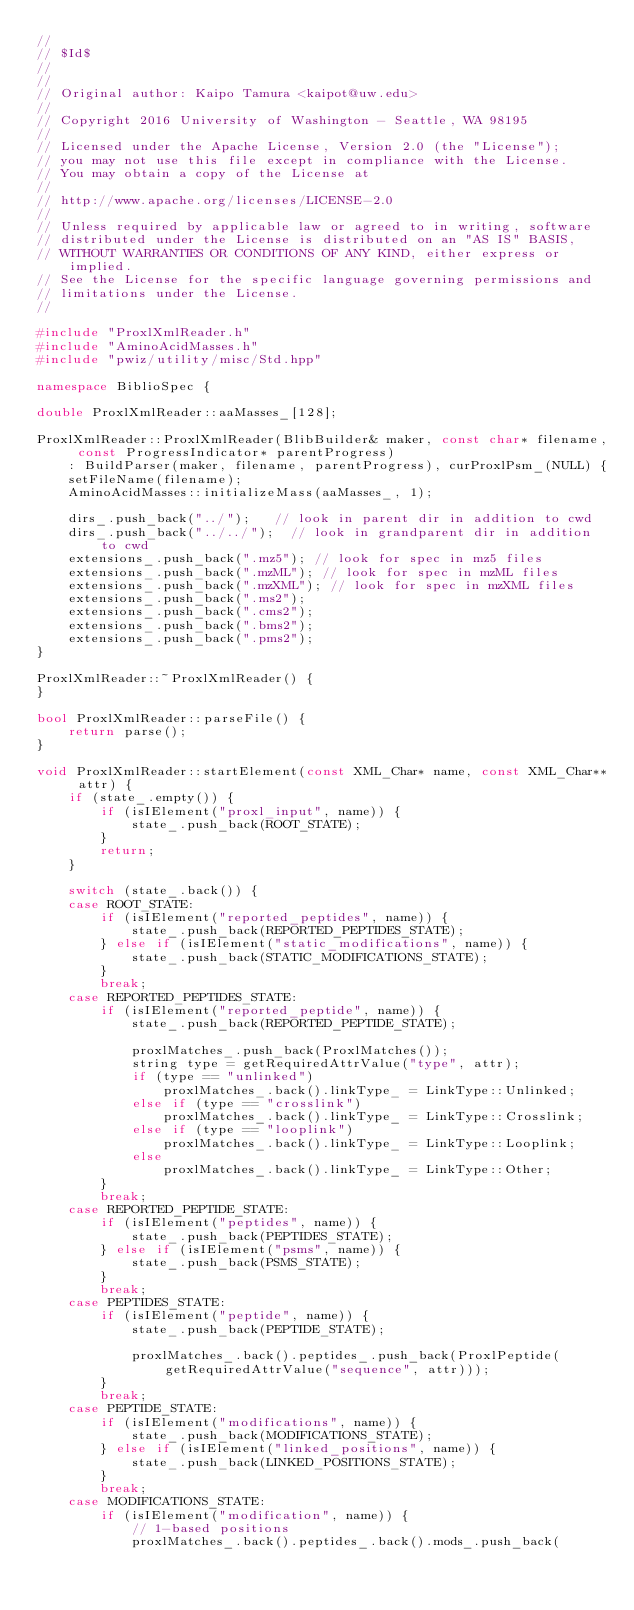Convert code to text. <code><loc_0><loc_0><loc_500><loc_500><_C++_>//
// $Id$
//
//
// Original author: Kaipo Tamura <kaipot@uw.edu>
//
// Copyright 2016 University of Washington - Seattle, WA 98195
//
// Licensed under the Apache License, Version 2.0 (the "License"); 
// you may not use this file except in compliance with the License. 
// You may obtain a copy of the License at 
//
// http://www.apache.org/licenses/LICENSE-2.0
//
// Unless required by applicable law or agreed to in writing, software 
// distributed under the License is distributed on an "AS IS" BASIS, 
// WITHOUT WARRANTIES OR CONDITIONS OF ANY KIND, either express or implied. 
// See the License for the specific language governing permissions and 
// limitations under the License.
//

#include "ProxlXmlReader.h"
#include "AminoAcidMasses.h"
#include "pwiz/utility/misc/Std.hpp"

namespace BiblioSpec {

double ProxlXmlReader::aaMasses_[128];

ProxlXmlReader::ProxlXmlReader(BlibBuilder& maker, const char* filename, const ProgressIndicator* parentProgress)
    : BuildParser(maker, filename, parentProgress), curProxlPsm_(NULL) {
    setFileName(filename);
    AminoAcidMasses::initializeMass(aaMasses_, 1);

    dirs_.push_back("../");   // look in parent dir in addition to cwd
    dirs_.push_back("../../");  // look in grandparent dir in addition to cwd
    extensions_.push_back(".mz5"); // look for spec in mz5 files
    extensions_.push_back(".mzML"); // look for spec in mzML files
    extensions_.push_back(".mzXML"); // look for spec in mzXML files
    extensions_.push_back(".ms2");
    extensions_.push_back(".cms2");
    extensions_.push_back(".bms2");
    extensions_.push_back(".pms2");
}

ProxlXmlReader::~ProxlXmlReader() {
}

bool ProxlXmlReader::parseFile() {
    return parse();
}

void ProxlXmlReader::startElement(const XML_Char* name, const XML_Char** attr) {
    if (state_.empty()) {
        if (isIElement("proxl_input", name)) {
            state_.push_back(ROOT_STATE);
        }
        return;
    }
    
    switch (state_.back()) {
    case ROOT_STATE:
        if (isIElement("reported_peptides", name)) {
            state_.push_back(REPORTED_PEPTIDES_STATE);
        } else if (isIElement("static_modifications", name)) {
            state_.push_back(STATIC_MODIFICATIONS_STATE);
        }
        break;
    case REPORTED_PEPTIDES_STATE:
        if (isIElement("reported_peptide", name)) {
            state_.push_back(REPORTED_PEPTIDE_STATE);

            proxlMatches_.push_back(ProxlMatches());
            string type = getRequiredAttrValue("type", attr);
            if (type == "unlinked")
                proxlMatches_.back().linkType_ = LinkType::Unlinked;
            else if (type == "crosslink")
                proxlMatches_.back().linkType_ = LinkType::Crosslink;
            else if (type == "looplink")
                proxlMatches_.back().linkType_ = LinkType::Looplink;
            else
                proxlMatches_.back().linkType_ = LinkType::Other;
        }
        break;
    case REPORTED_PEPTIDE_STATE:
        if (isIElement("peptides", name)) {
            state_.push_back(PEPTIDES_STATE);
        } else if (isIElement("psms", name)) {
            state_.push_back(PSMS_STATE);
        }
        break;
    case PEPTIDES_STATE:
        if (isIElement("peptide", name)) {
            state_.push_back(PEPTIDE_STATE);

            proxlMatches_.back().peptides_.push_back(ProxlPeptide(getRequiredAttrValue("sequence", attr)));
        }
        break;
    case PEPTIDE_STATE:
        if (isIElement("modifications", name)) {
            state_.push_back(MODIFICATIONS_STATE);
        } else if (isIElement("linked_positions", name)) {
            state_.push_back(LINKED_POSITIONS_STATE);
        }
        break;
    case MODIFICATIONS_STATE:
        if (isIElement("modification", name)) {
            // 1-based positions
            proxlMatches_.back().peptides_.back().mods_.push_back(</code> 